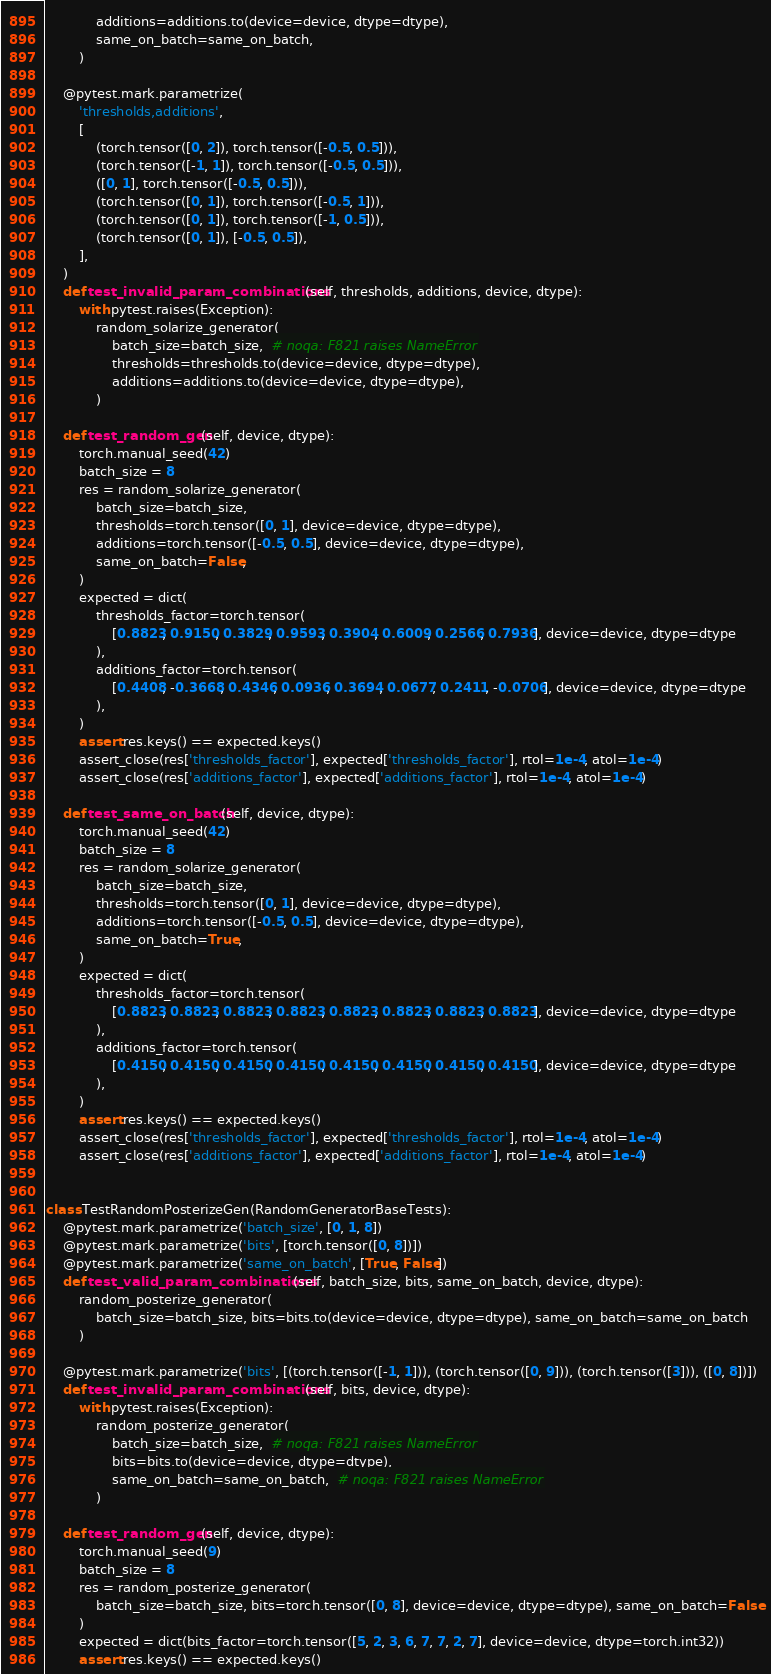Convert code to text. <code><loc_0><loc_0><loc_500><loc_500><_Python_>            additions=additions.to(device=device, dtype=dtype),
            same_on_batch=same_on_batch,
        )

    @pytest.mark.parametrize(
        'thresholds,additions',
        [
            (torch.tensor([0, 2]), torch.tensor([-0.5, 0.5])),
            (torch.tensor([-1, 1]), torch.tensor([-0.5, 0.5])),
            ([0, 1], torch.tensor([-0.5, 0.5])),
            (torch.tensor([0, 1]), torch.tensor([-0.5, 1])),
            (torch.tensor([0, 1]), torch.tensor([-1, 0.5])),
            (torch.tensor([0, 1]), [-0.5, 0.5]),
        ],
    )
    def test_invalid_param_combinations(self, thresholds, additions, device, dtype):
        with pytest.raises(Exception):
            random_solarize_generator(
                batch_size=batch_size,  # noqa: F821 raises NameError
                thresholds=thresholds.to(device=device, dtype=dtype),
                additions=additions.to(device=device, dtype=dtype),
            )

    def test_random_gen(self, device, dtype):
        torch.manual_seed(42)
        batch_size = 8
        res = random_solarize_generator(
            batch_size=batch_size,
            thresholds=torch.tensor([0, 1], device=device, dtype=dtype),
            additions=torch.tensor([-0.5, 0.5], device=device, dtype=dtype),
            same_on_batch=False,
        )
        expected = dict(
            thresholds_factor=torch.tensor(
                [0.8823, 0.9150, 0.3829, 0.9593, 0.3904, 0.6009, 0.2566, 0.7936], device=device, dtype=dtype
            ),
            additions_factor=torch.tensor(
                [0.4408, -0.3668, 0.4346, 0.0936, 0.3694, 0.0677, 0.2411, -0.0706], device=device, dtype=dtype
            ),
        )
        assert res.keys() == expected.keys()
        assert_close(res['thresholds_factor'], expected['thresholds_factor'], rtol=1e-4, atol=1e-4)
        assert_close(res['additions_factor'], expected['additions_factor'], rtol=1e-4, atol=1e-4)

    def test_same_on_batch(self, device, dtype):
        torch.manual_seed(42)
        batch_size = 8
        res = random_solarize_generator(
            batch_size=batch_size,
            thresholds=torch.tensor([0, 1], device=device, dtype=dtype),
            additions=torch.tensor([-0.5, 0.5], device=device, dtype=dtype),
            same_on_batch=True,
        )
        expected = dict(
            thresholds_factor=torch.tensor(
                [0.8823, 0.8823, 0.8823, 0.8823, 0.8823, 0.8823, 0.8823, 0.8823], device=device, dtype=dtype
            ),
            additions_factor=torch.tensor(
                [0.4150, 0.4150, 0.4150, 0.4150, 0.4150, 0.4150, 0.4150, 0.4150], device=device, dtype=dtype
            ),
        )
        assert res.keys() == expected.keys()
        assert_close(res['thresholds_factor'], expected['thresholds_factor'], rtol=1e-4, atol=1e-4)
        assert_close(res['additions_factor'], expected['additions_factor'], rtol=1e-4, atol=1e-4)


class TestRandomPosterizeGen(RandomGeneratorBaseTests):
    @pytest.mark.parametrize('batch_size', [0, 1, 8])
    @pytest.mark.parametrize('bits', [torch.tensor([0, 8])])
    @pytest.mark.parametrize('same_on_batch', [True, False])
    def test_valid_param_combinations(self, batch_size, bits, same_on_batch, device, dtype):
        random_posterize_generator(
            batch_size=batch_size, bits=bits.to(device=device, dtype=dtype), same_on_batch=same_on_batch
        )

    @pytest.mark.parametrize('bits', [(torch.tensor([-1, 1])), (torch.tensor([0, 9])), (torch.tensor([3])), ([0, 8])])
    def test_invalid_param_combinations(self, bits, device, dtype):
        with pytest.raises(Exception):
            random_posterize_generator(
                batch_size=batch_size,  # noqa: F821 raises NameError
                bits=bits.to(device=device, dtype=dtype),
                same_on_batch=same_on_batch,  # noqa: F821 raises NameError
            )

    def test_random_gen(self, device, dtype):
        torch.manual_seed(9)
        batch_size = 8
        res = random_posterize_generator(
            batch_size=batch_size, bits=torch.tensor([0, 8], device=device, dtype=dtype), same_on_batch=False
        )
        expected = dict(bits_factor=torch.tensor([5, 2, 3, 6, 7, 7, 2, 7], device=device, dtype=torch.int32))
        assert res.keys() == expected.keys()</code> 